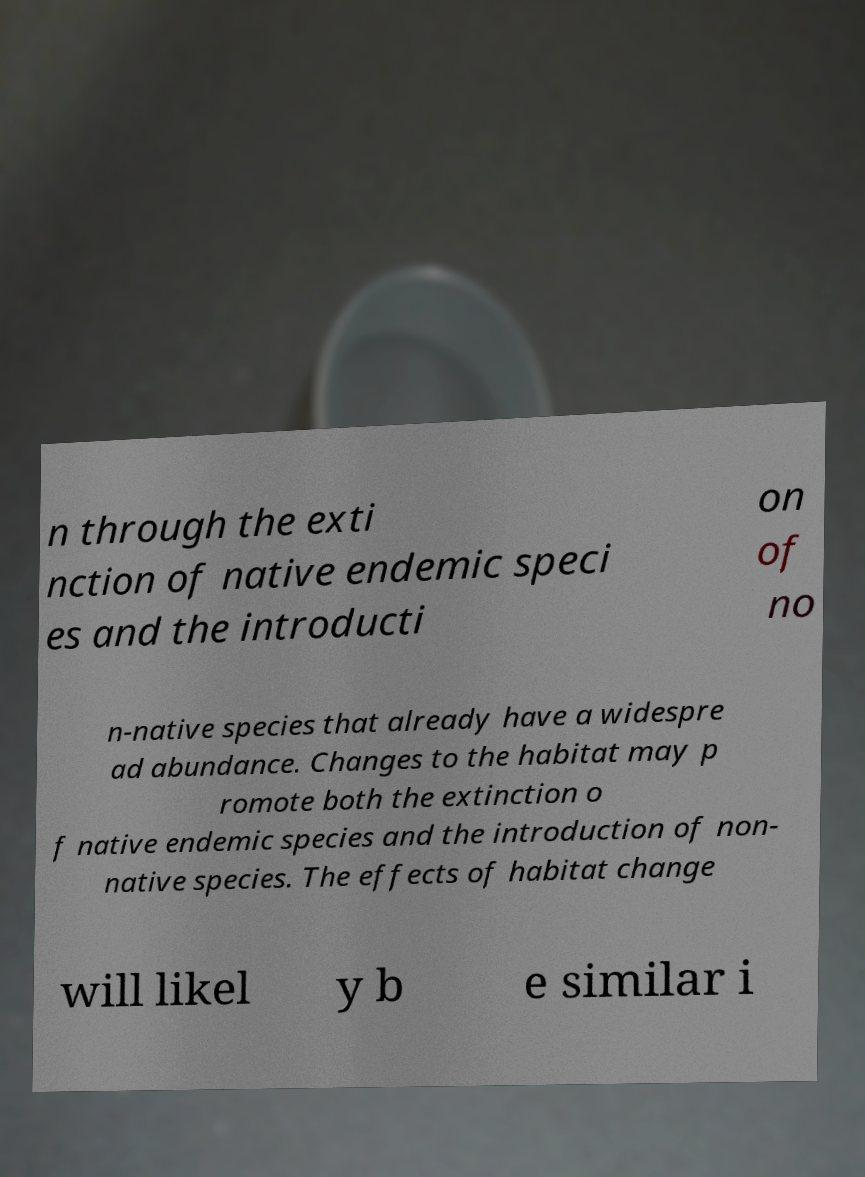There's text embedded in this image that I need extracted. Can you transcribe it verbatim? n through the exti nction of native endemic speci es and the introducti on of no n-native species that already have a widespre ad abundance. Changes to the habitat may p romote both the extinction o f native endemic species and the introduction of non- native species. The effects of habitat change will likel y b e similar i 